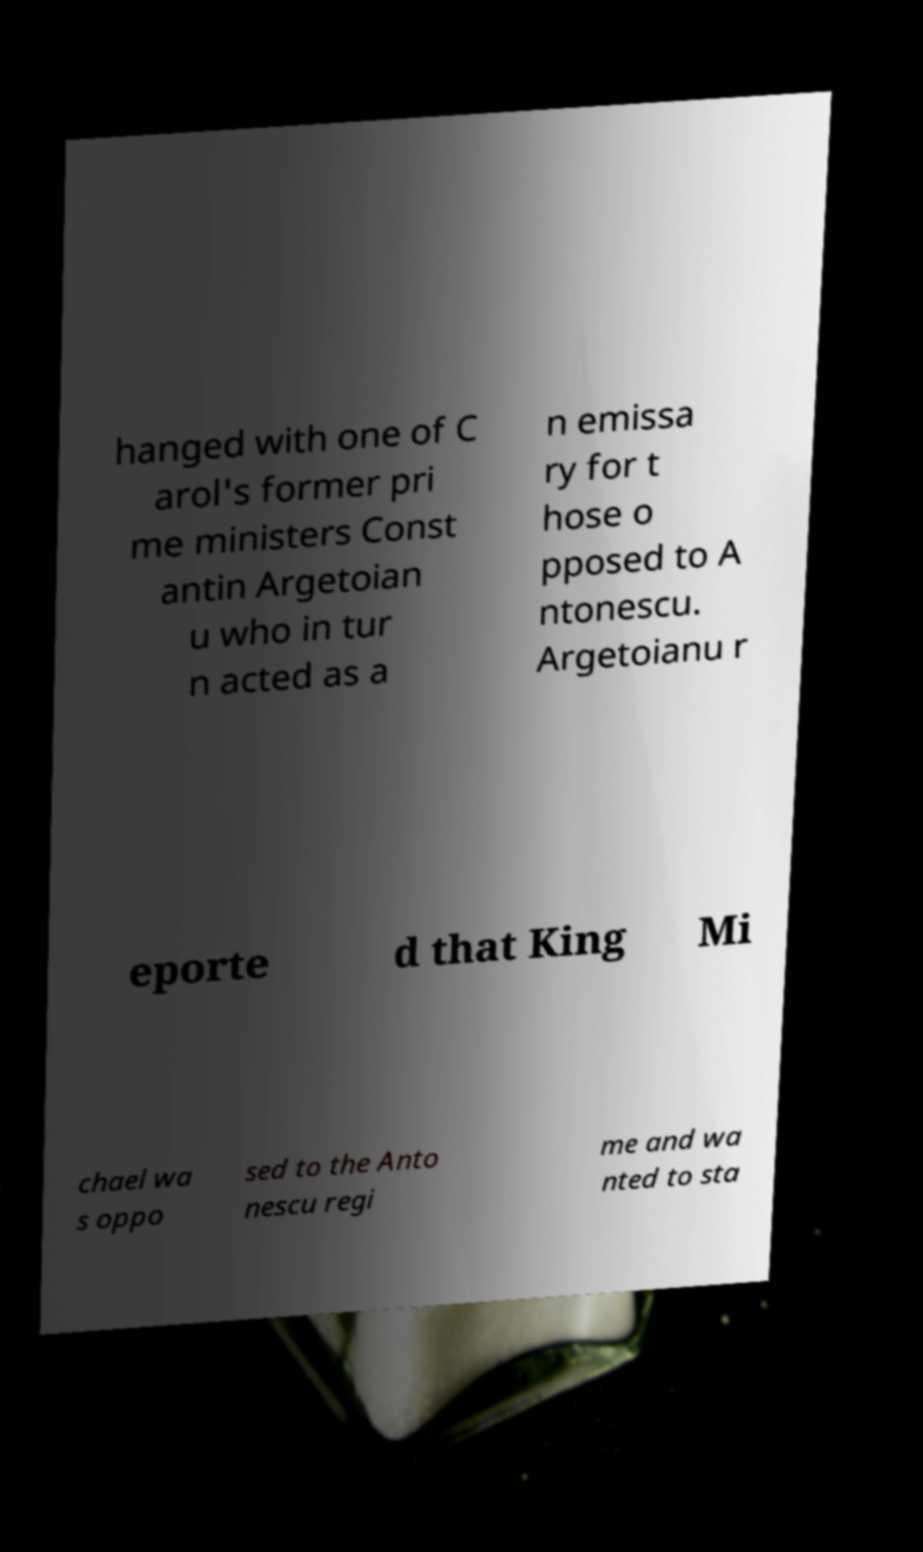Could you extract and type out the text from this image? hanged with one of C arol's former pri me ministers Const antin Argetoian u who in tur n acted as a n emissa ry for t hose o pposed to A ntonescu. Argetoianu r eporte d that King Mi chael wa s oppo sed to the Anto nescu regi me and wa nted to sta 